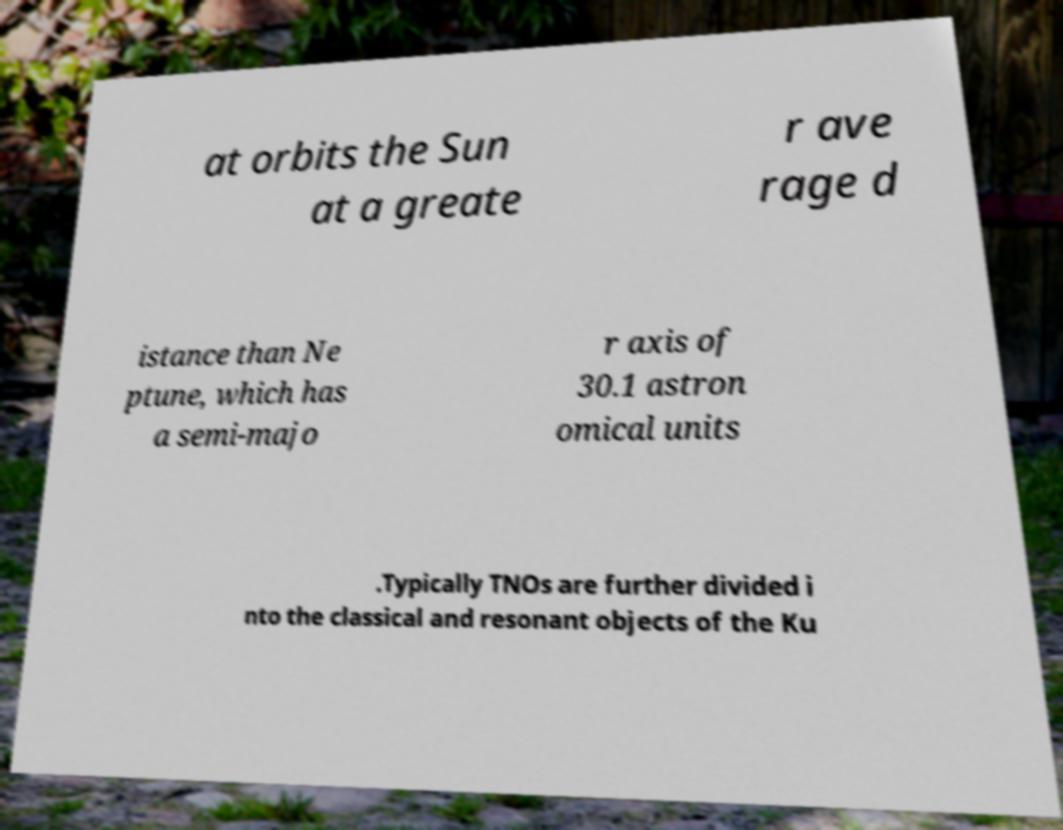Please read and relay the text visible in this image. What does it say? at orbits the Sun at a greate r ave rage d istance than Ne ptune, which has a semi-majo r axis of 30.1 astron omical units .Typically TNOs are further divided i nto the classical and resonant objects of the Ku 